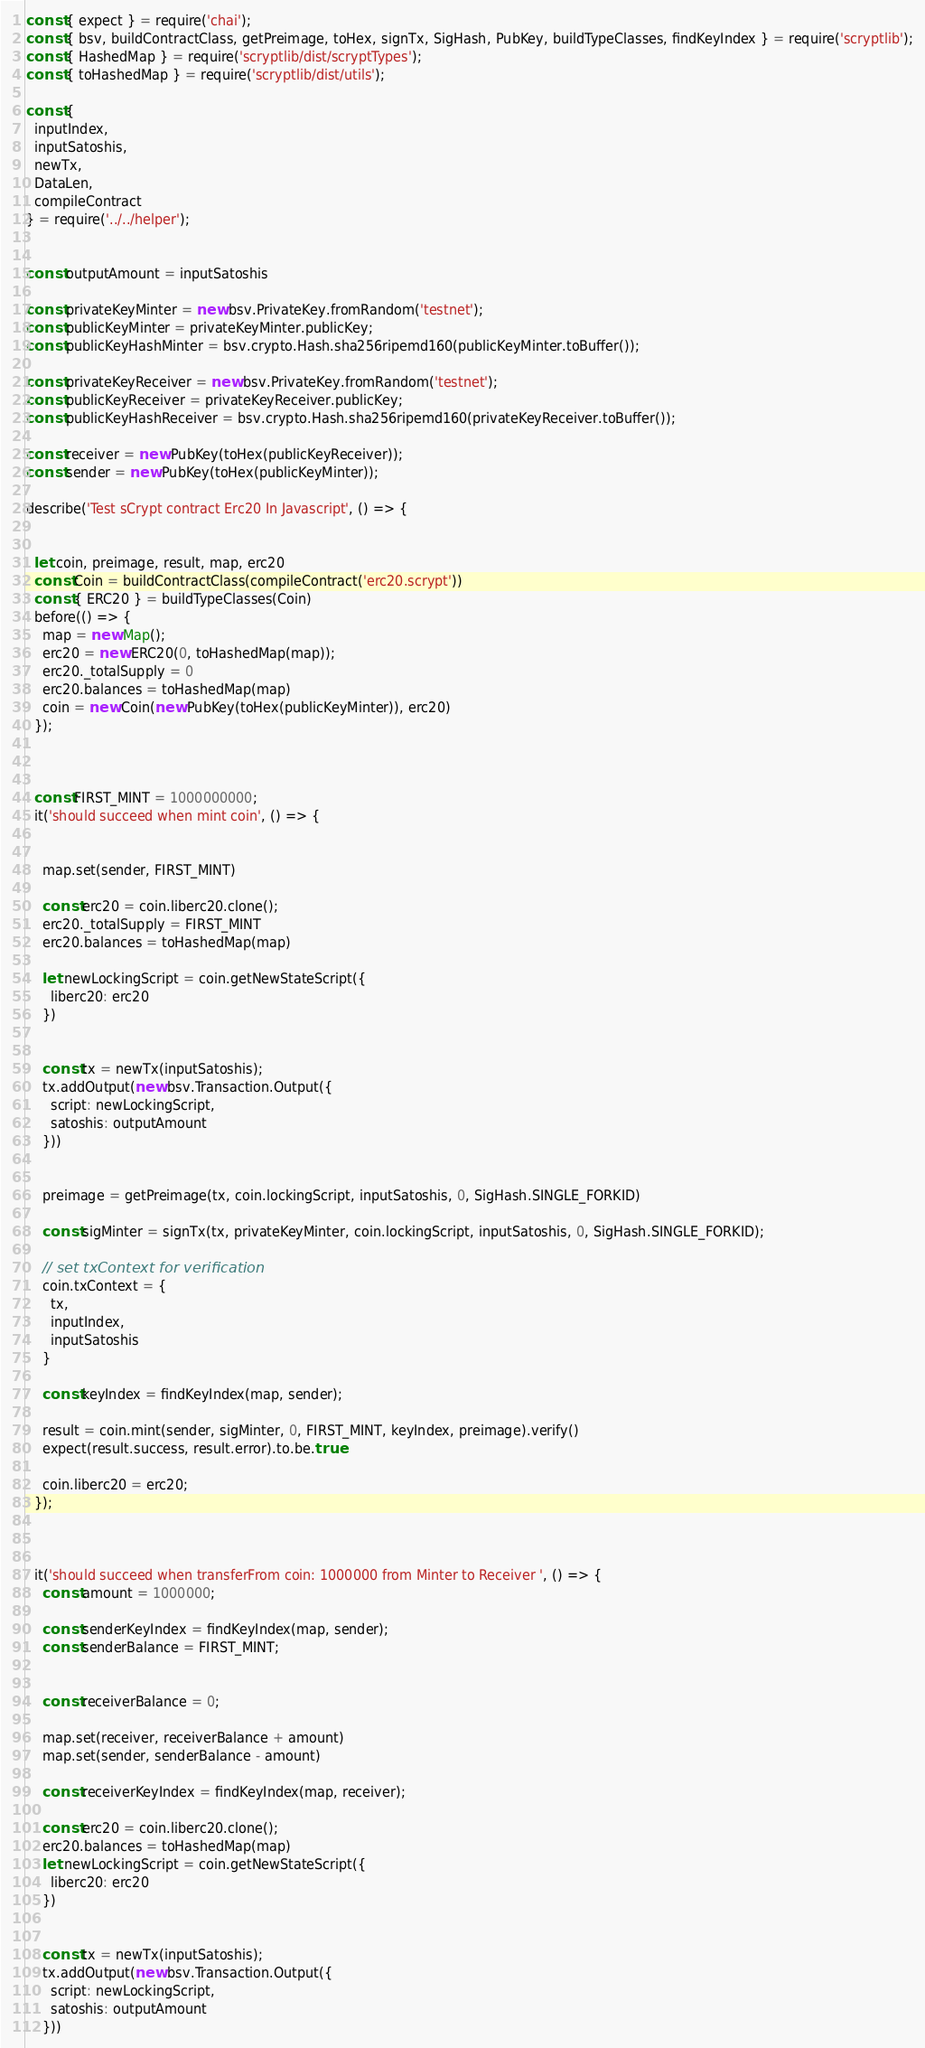Convert code to text. <code><loc_0><loc_0><loc_500><loc_500><_JavaScript_>const { expect } = require('chai');
const { bsv, buildContractClass, getPreimage, toHex, signTx, SigHash, PubKey, buildTypeClasses, findKeyIndex } = require('scryptlib');
const { HashedMap } = require('scryptlib/dist/scryptTypes');
const { toHashedMap } = require('scryptlib/dist/utils');

const {
  inputIndex,
  inputSatoshis,
  newTx,
  DataLen,
  compileContract
} = require('../../helper');


const outputAmount = inputSatoshis

const privateKeyMinter = new bsv.PrivateKey.fromRandom('testnet');
const publicKeyMinter = privateKeyMinter.publicKey;
const publicKeyHashMinter = bsv.crypto.Hash.sha256ripemd160(publicKeyMinter.toBuffer());

const privateKeyReceiver = new bsv.PrivateKey.fromRandom('testnet');
const publicKeyReceiver = privateKeyReceiver.publicKey;
const publicKeyHashReceiver = bsv.crypto.Hash.sha256ripemd160(privateKeyReceiver.toBuffer());

const receiver = new PubKey(toHex(publicKeyReceiver));
const sender = new PubKey(toHex(publicKeyMinter));

describe('Test sCrypt contract Erc20 In Javascript', () => {
  

  let coin, preimage, result, map, erc20
  const Coin = buildContractClass(compileContract('erc20.scrypt'))
  const { ERC20 } = buildTypeClasses(Coin)
  before(() => {
    map = new Map();
    erc20 = new ERC20(0, toHashedMap(map));
    erc20._totalSupply = 0
    erc20.balances = toHashedMap(map)
    coin = new Coin(new PubKey(toHex(publicKeyMinter)), erc20)
  });


  
  const FIRST_MINT = 1000000000;
  it('should succeed when mint coin', () => {


    map.set(sender, FIRST_MINT)

    const erc20 = coin.liberc20.clone();
    erc20._totalSupply = FIRST_MINT
    erc20.balances = toHashedMap(map)

    let newLockingScript = coin.getNewStateScript({
      liberc20: erc20
    })


    const tx = newTx(inputSatoshis);
    tx.addOutput(new bsv.Transaction.Output({
      script: newLockingScript,
      satoshis: outputAmount
    }))


    preimage = getPreimage(tx, coin.lockingScript, inputSatoshis, 0, SigHash.SINGLE_FORKID)

    const sigMinter = signTx(tx, privateKeyMinter, coin.lockingScript, inputSatoshis, 0, SigHash.SINGLE_FORKID);

    // set txContext for verification
    coin.txContext = {
      tx,
      inputIndex,
      inputSatoshis
    }

    const keyIndex = findKeyIndex(map, sender);

    result = coin.mint(sender, sigMinter, 0, FIRST_MINT, keyIndex, preimage).verify()
    expect(result.success, result.error).to.be.true

    coin.liberc20 = erc20;
  });



  it('should succeed when transferFrom coin: 1000000 from Minter to Receiver ', () => {
    const amount = 1000000;

    const senderKeyIndex = findKeyIndex(map, sender);
    const senderBalance = FIRST_MINT;


    const receiverBalance = 0;

    map.set(receiver, receiverBalance + amount)
    map.set(sender, senderBalance - amount)

    const receiverKeyIndex = findKeyIndex(map, receiver);

    const erc20 = coin.liberc20.clone();
    erc20.balances = toHashedMap(map)
    let newLockingScript = coin.getNewStateScript({
      liberc20: erc20
    })


    const tx = newTx(inputSatoshis);
    tx.addOutput(new bsv.Transaction.Output({
      script: newLockingScript,
      satoshis: outputAmount
    }))

</code> 